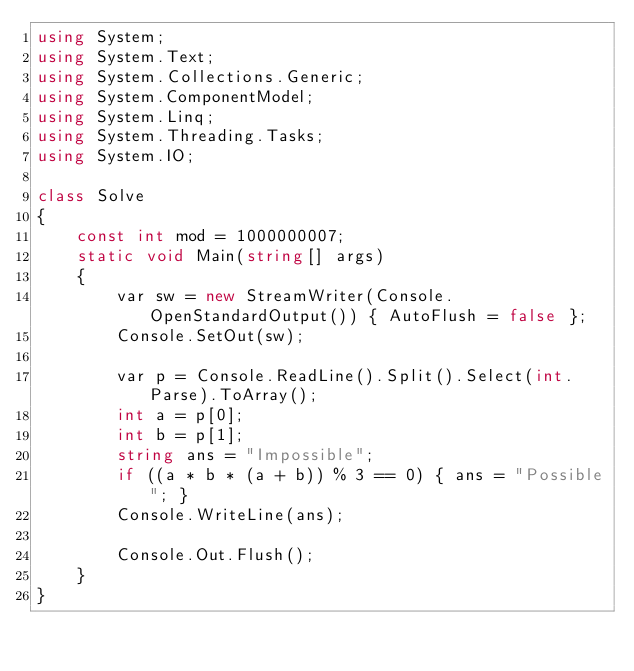Convert code to text. <code><loc_0><loc_0><loc_500><loc_500><_C#_>using System;
using System.Text;
using System.Collections.Generic;
using System.ComponentModel;
using System.Linq;
using System.Threading.Tasks;
using System.IO;

class Solve
{
	const int mod = 1000000007;
	static void Main(string[] args)
	{
        var sw = new StreamWriter(Console.OpenStandardOutput()) { AutoFlush = false };
		Console.SetOut(sw);

		var p = Console.ReadLine().Split().Select(int.Parse).ToArray();
		int a = p[0];
		int b = p[1];
		string ans = "Impossible";
		if ((a * b * (a + b)) % 3 == 0) { ans = "Possible"; }
		Console.WriteLine(ans);

		Console.Out.Flush();
	}
}
</code> 